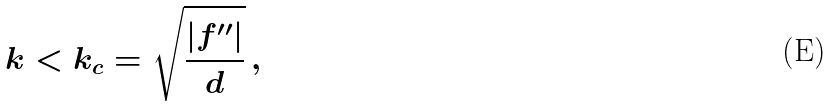<formula> <loc_0><loc_0><loc_500><loc_500>k < k _ { c } = \sqrt { \frac { | f ^ { \prime \prime } | } { d } } \, ,</formula> 